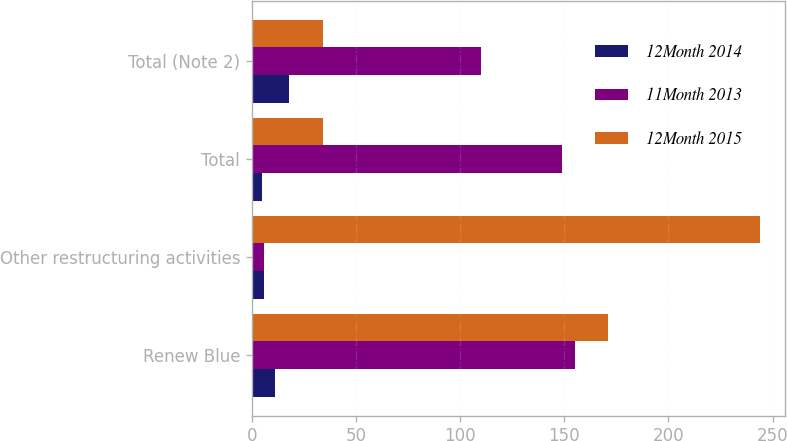Convert chart to OTSL. <chart><loc_0><loc_0><loc_500><loc_500><stacked_bar_chart><ecel><fcel>Renew Blue<fcel>Other restructuring activities<fcel>Total<fcel>Total (Note 2)<nl><fcel>12Month 2014<fcel>11<fcel>6<fcel>5<fcel>18<nl><fcel>11Month 2013<fcel>155<fcel>6<fcel>149<fcel>110<nl><fcel>12Month 2015<fcel>171<fcel>244<fcel>34<fcel>34<nl></chart> 